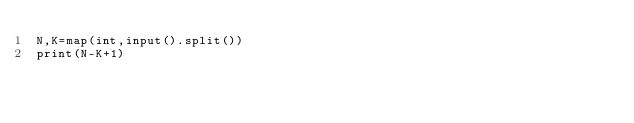<code> <loc_0><loc_0><loc_500><loc_500><_Python_>N,K=map(int,input().split())
print(N-K+1)</code> 